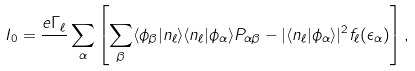Convert formula to latex. <formula><loc_0><loc_0><loc_500><loc_500>I _ { 0 } = \frac { e \Gamma _ { \ell } } { } \sum _ { \alpha } \left [ \sum _ { \beta } \langle \phi _ { \beta } | n _ { \ell } \rangle \langle n _ { \ell } | \phi _ { \alpha } \rangle P _ { \alpha \beta } - | \langle n _ { \ell } | \phi _ { \alpha } \rangle | ^ { 2 } f _ { \ell } ( \epsilon _ { \alpha } ) \right ] ,</formula> 